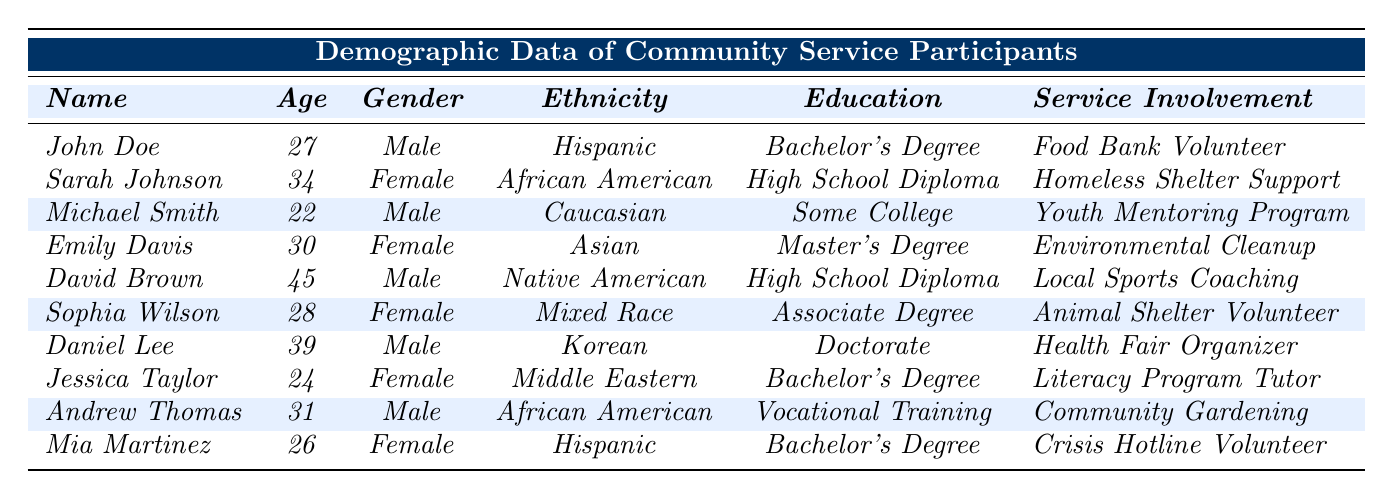What is the gender of Jessica Taylor? The table directly shows that Jessica Taylor is listed as Female in the Gender column.
Answer: Female How many participants have a Bachelor's Degree? By examining the Education Level column, I can identify that John Doe, Jessica Taylor, Mia Martinez, and Emily Davis each have a Bachelor's Degree, totaling four participants.
Answer: 4 Which age group contains the oldest participant? David Brown, at 45 years old, holds the highest age value in the Age column.
Answer: 45 years old Does any participant have a Doctorate degree? The table lists Daniel Lee with a Doctorate in the Education column, confirming that at least one participant has this degree.
Answer: Yes How many male participants are involved in community service? From the Gender column, I count four males: John Doe, Michael Smith, David Brown, and Daniel Lee.
Answer: 4 What community service involves the youngest participant? Michael Smith, who is 22 years old, is involved in the Youth Mentoring Program, as noted in the Community Service Involvement column.
Answer: Youth Mentoring Program Is there any participant involved in animal shelter volunteering? Sophia Wilson is the participant listed with Animal Shelter Volunteer in the Community Service Involvement column, indicating that the answer is yes.
Answer: Yes What is the average age of all participants in community service? Adding up the ages (27 + 34 + 22 + 30 + 45 + 28 + 39 + 24 + 31 + 26) gives a total of  306 ages. Dividing by 10 participants results in an average age of 30.6.
Answer: 30.6 How many participants with a High School Diploma are involved in community service? The table shows two participants, Sarah Johnson and David Brown, with a High School Diploma in the Education Level column.
Answer: 2 Which education level is most common among the participants? Looking at the Education Level column, Bachelor's Degree appears four times, more than any other level, indicating it is the most common.
Answer: Bachelor's Degree 